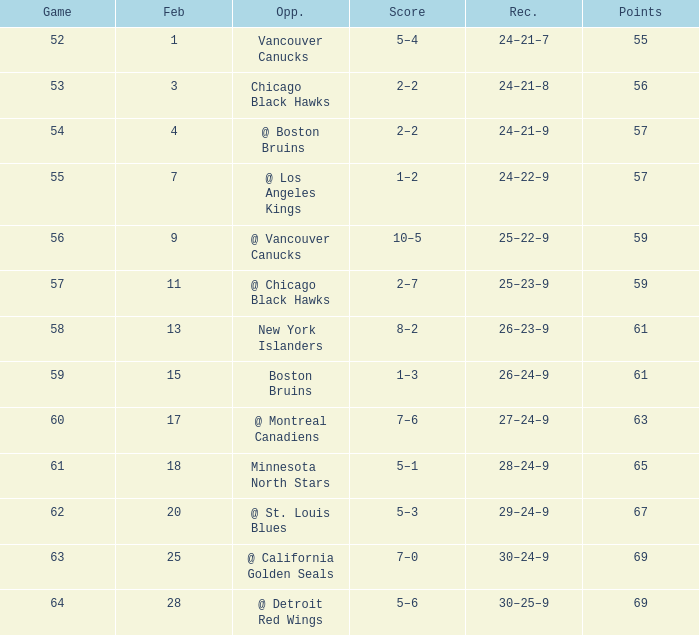How many february games had a record of 29–24–9? 20.0. 